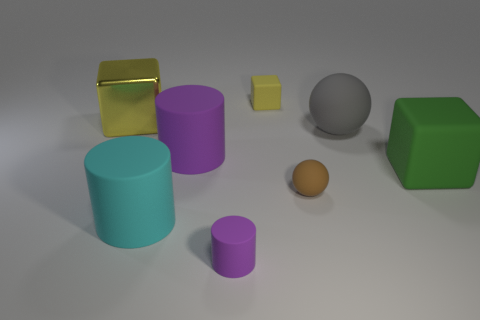Can you determine the lighting direction in this image? Yes, the lighting in the scene seems to be coming from the top left side, as indicated by the shadows projecting towards the bottom right. How does the lighting affect the appearance of the colors and materials of the objects? The lighting enhances the colors, making them more vivid, and it also accentuates the differences in material properties, such as the varying reflections and textures. 